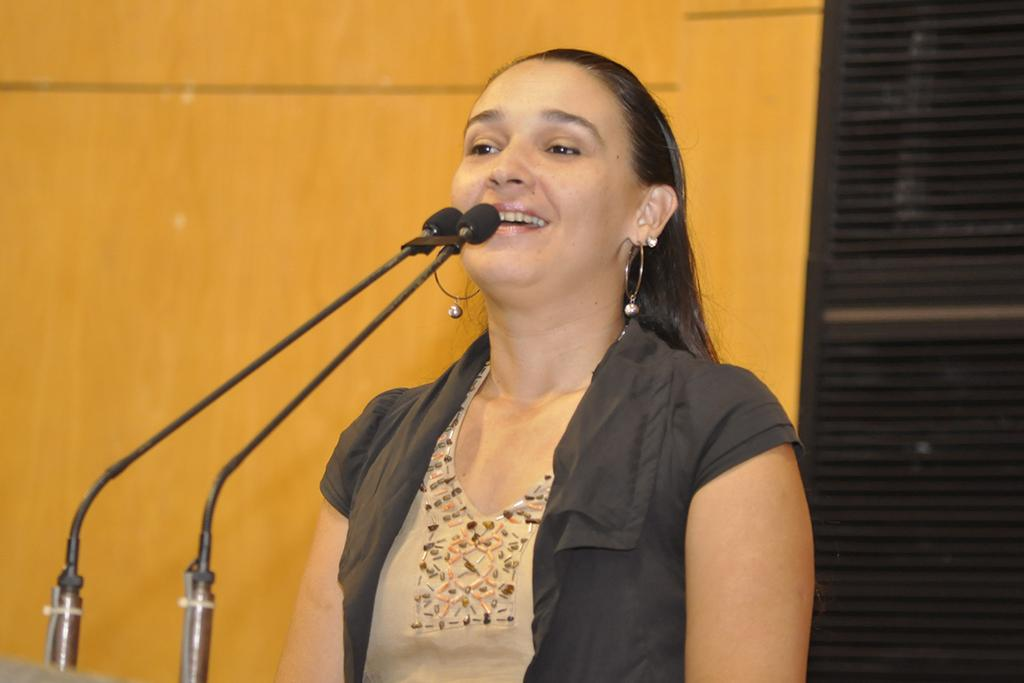Who is present in the image? There is a woman in the image. What is the woman doing in the image? The woman is standing in the image. What accessories is the woman wearing? The woman is wearing earrings in the image. What expression does the woman have? The woman is smiling in the image. What can be seen on the left side of the image? There are microphones on the left side of the image. What is visible in the background of the image? There is a wall in the background of the image. What type of pet is the woman holding in the image? There is no pet present in the image. 